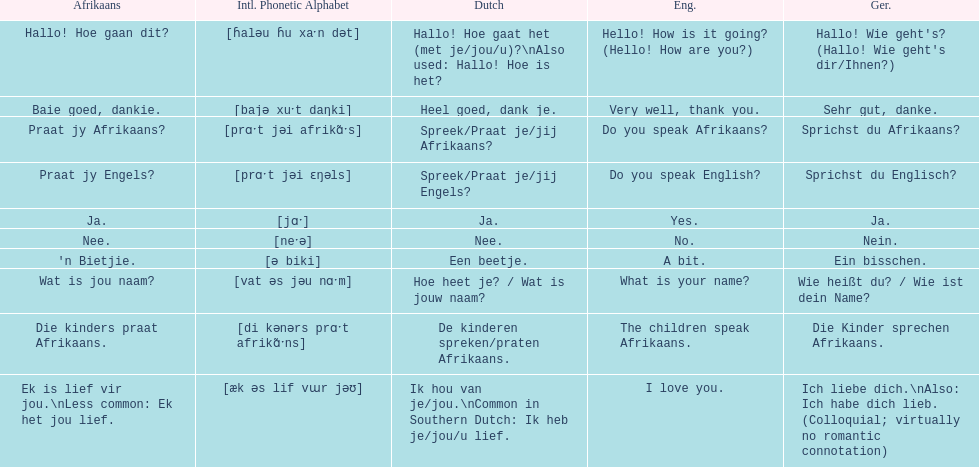How do you say 'i love you' in afrikaans? Ek is lief vir jou. 